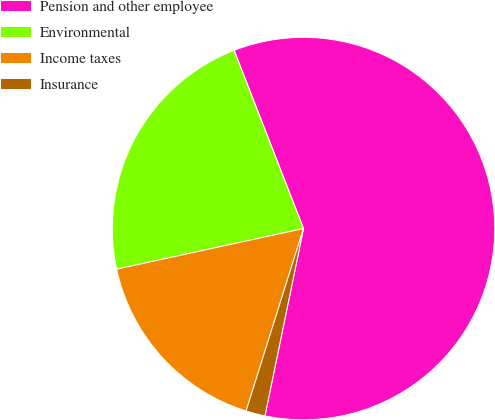<chart> <loc_0><loc_0><loc_500><loc_500><pie_chart><fcel>Pension and other employee<fcel>Environmental<fcel>Income taxes<fcel>Insurance<nl><fcel>59.14%<fcel>22.5%<fcel>16.74%<fcel>1.62%<nl></chart> 